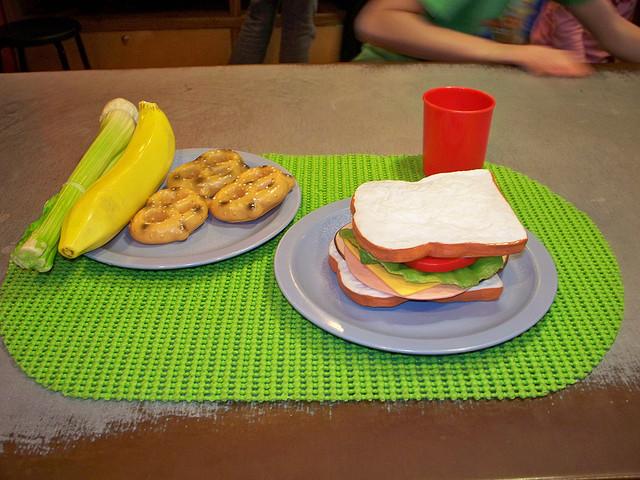Is this food edible?
Quick response, please. No. What fruit is on the plates?
Concise answer only. Banana. Is there a banana on the plate?
Write a very short answer. Yes. Is the cup blue?
Be succinct. No. 